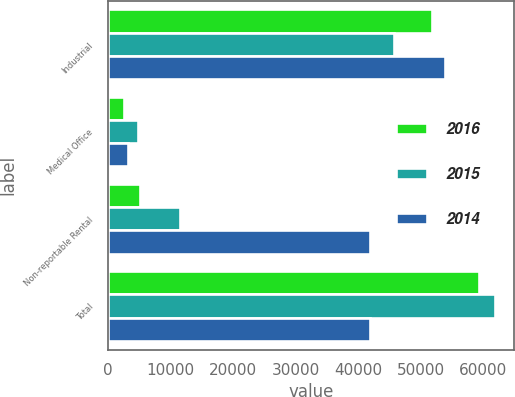Convert chart. <chart><loc_0><loc_0><loc_500><loc_500><stacked_bar_chart><ecel><fcel>Industrial<fcel>Medical Office<fcel>Non-reportable Rental<fcel>Total<nl><fcel>2016<fcel>51785<fcel>2515<fcel>5049<fcel>59349<nl><fcel>2015<fcel>45716<fcel>4711<fcel>11473<fcel>61900<nl><fcel>2014<fcel>53840<fcel>3131<fcel>41850<fcel>41850<nl></chart> 